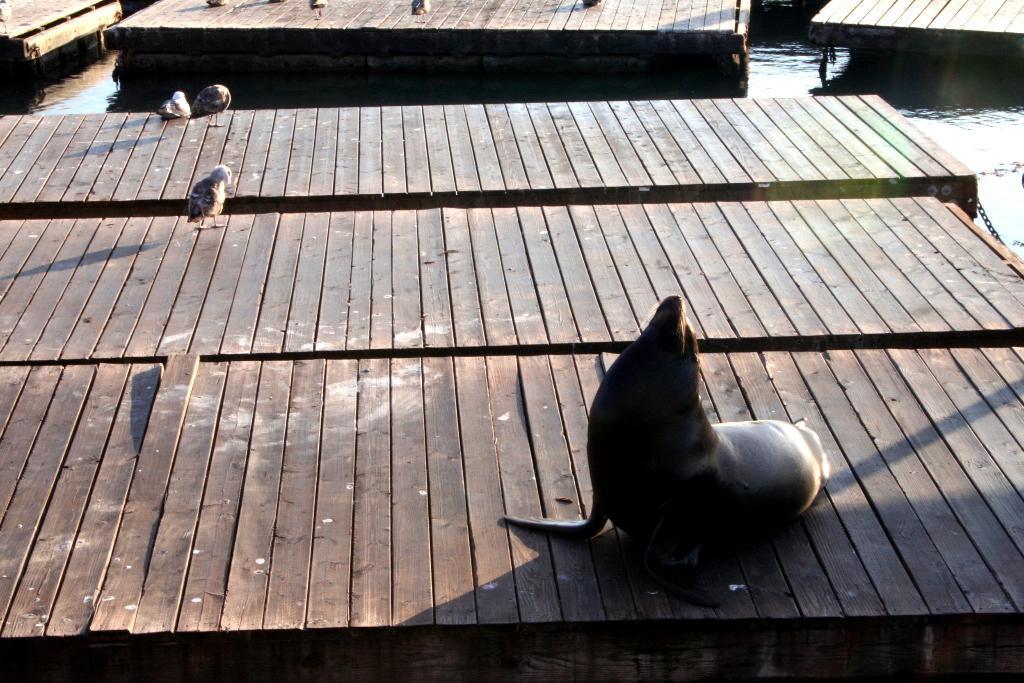Please provide a concise description of this image. In this image I can see a seal and the birds on the wooden surface. These wooden surface is on the water. To the right I can see the chain. 